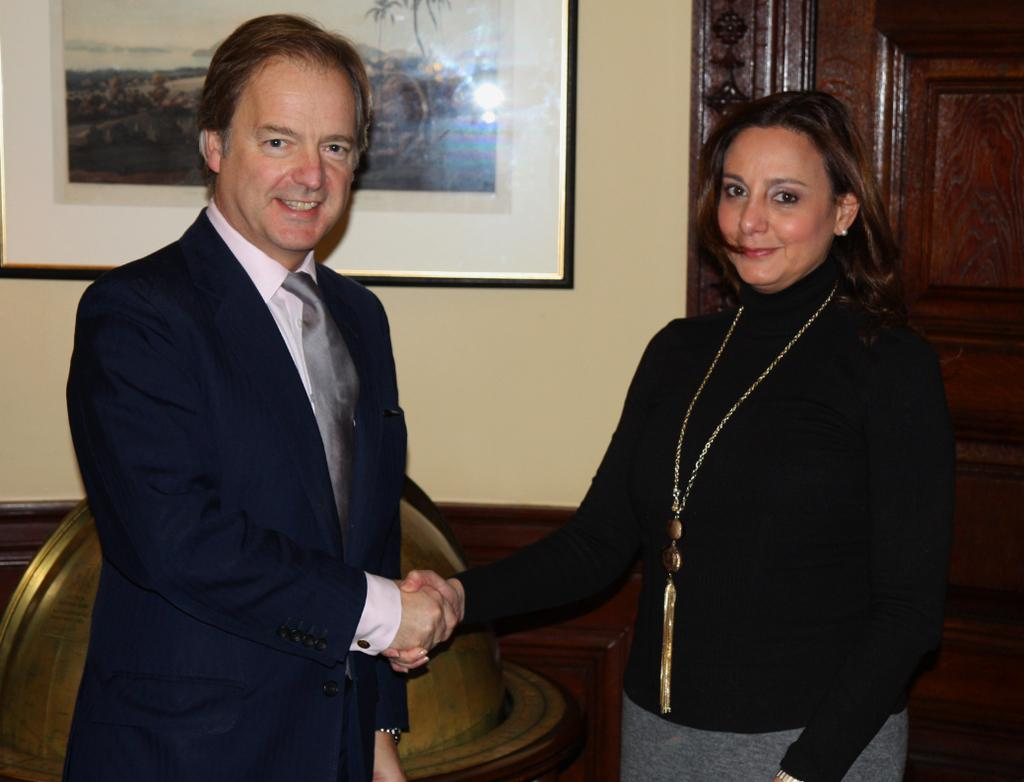Who are the people in the image? There is a man and a woman standing in the image. What object can be seen in the background of the image? There is a globe visible in the image. What architectural feature is present in the image? There is a door in the image. What type of decoration is on the wall in the image? There is a photo frame on a wall in the image. What is the weight of the shape that is not present in the image? There is no shape mentioned or present in the image, so it is impossible to determine its weight. 